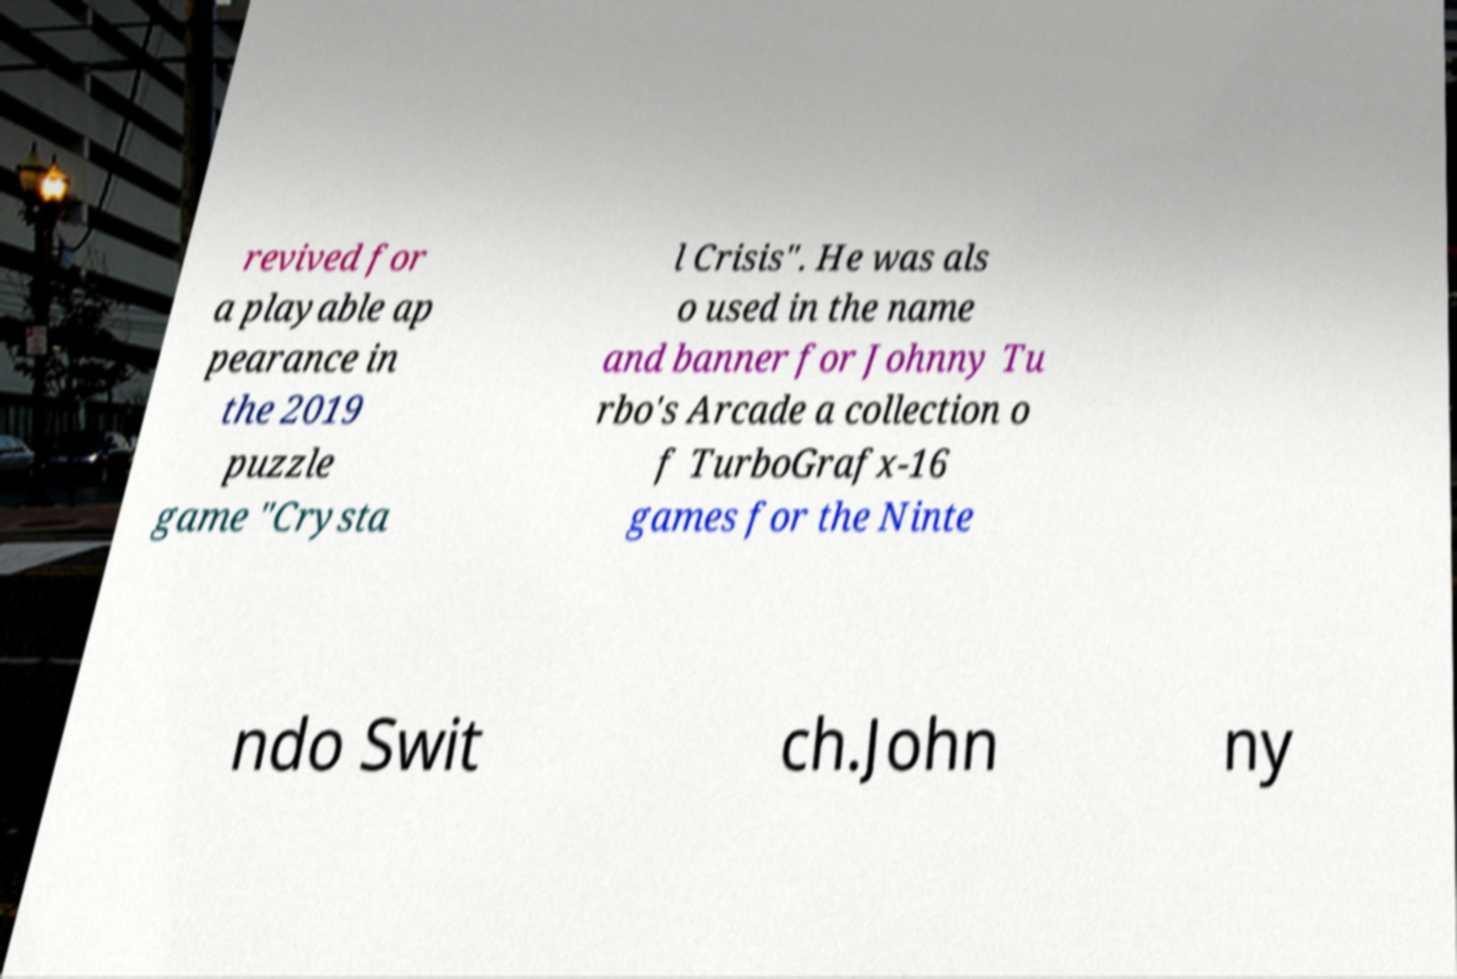Can you accurately transcribe the text from the provided image for me? revived for a playable ap pearance in the 2019 puzzle game "Crysta l Crisis". He was als o used in the name and banner for Johnny Tu rbo's Arcade a collection o f TurboGrafx-16 games for the Ninte ndo Swit ch.John ny 